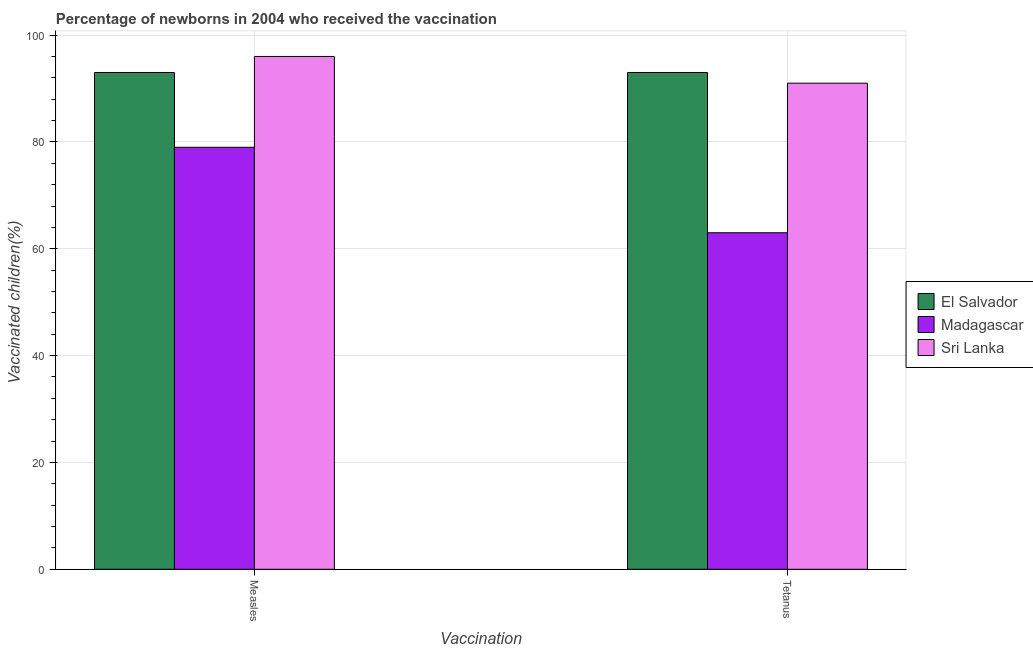How many different coloured bars are there?
Your answer should be very brief. 3. How many groups of bars are there?
Keep it short and to the point. 2. Are the number of bars on each tick of the X-axis equal?
Keep it short and to the point. Yes. How many bars are there on the 2nd tick from the left?
Give a very brief answer. 3. How many bars are there on the 1st tick from the right?
Provide a short and direct response. 3. What is the label of the 1st group of bars from the left?
Make the answer very short. Measles. What is the percentage of newborns who received vaccination for measles in El Salvador?
Offer a terse response. 93. Across all countries, what is the maximum percentage of newborns who received vaccination for measles?
Your response must be concise. 96. Across all countries, what is the minimum percentage of newborns who received vaccination for tetanus?
Ensure brevity in your answer.  63. In which country was the percentage of newborns who received vaccination for tetanus maximum?
Your answer should be compact. El Salvador. In which country was the percentage of newborns who received vaccination for tetanus minimum?
Your response must be concise. Madagascar. What is the total percentage of newborns who received vaccination for measles in the graph?
Make the answer very short. 268. What is the difference between the percentage of newborns who received vaccination for tetanus in Madagascar and that in Sri Lanka?
Offer a terse response. -28. What is the difference between the percentage of newborns who received vaccination for measles in Madagascar and the percentage of newborns who received vaccination for tetanus in Sri Lanka?
Offer a very short reply. -12. What is the average percentage of newborns who received vaccination for tetanus per country?
Keep it short and to the point. 82.33. What is the difference between the percentage of newborns who received vaccination for tetanus and percentage of newborns who received vaccination for measles in El Salvador?
Your answer should be very brief. 0. In how many countries, is the percentage of newborns who received vaccination for measles greater than 12 %?
Keep it short and to the point. 3. What is the ratio of the percentage of newborns who received vaccination for tetanus in Sri Lanka to that in El Salvador?
Your response must be concise. 0.98. In how many countries, is the percentage of newborns who received vaccination for tetanus greater than the average percentage of newborns who received vaccination for tetanus taken over all countries?
Give a very brief answer. 2. What does the 3rd bar from the left in Tetanus represents?
Keep it short and to the point. Sri Lanka. What does the 1st bar from the right in Tetanus represents?
Provide a short and direct response. Sri Lanka. How many bars are there?
Give a very brief answer. 6. Are all the bars in the graph horizontal?
Your answer should be very brief. No. How many countries are there in the graph?
Offer a very short reply. 3. What is the difference between two consecutive major ticks on the Y-axis?
Make the answer very short. 20. Does the graph contain any zero values?
Your answer should be very brief. No. Where does the legend appear in the graph?
Ensure brevity in your answer.  Center right. How are the legend labels stacked?
Provide a succinct answer. Vertical. What is the title of the graph?
Make the answer very short. Percentage of newborns in 2004 who received the vaccination. What is the label or title of the X-axis?
Give a very brief answer. Vaccination. What is the label or title of the Y-axis?
Your answer should be very brief. Vaccinated children(%)
. What is the Vaccinated children(%)
 of El Salvador in Measles?
Offer a very short reply. 93. What is the Vaccinated children(%)
 of Madagascar in Measles?
Provide a short and direct response. 79. What is the Vaccinated children(%)
 of Sri Lanka in Measles?
Offer a very short reply. 96. What is the Vaccinated children(%)
 in El Salvador in Tetanus?
Provide a short and direct response. 93. What is the Vaccinated children(%)
 of Madagascar in Tetanus?
Give a very brief answer. 63. What is the Vaccinated children(%)
 in Sri Lanka in Tetanus?
Your answer should be compact. 91. Across all Vaccination, what is the maximum Vaccinated children(%)
 in El Salvador?
Your response must be concise. 93. Across all Vaccination, what is the maximum Vaccinated children(%)
 in Madagascar?
Provide a succinct answer. 79. Across all Vaccination, what is the maximum Vaccinated children(%)
 in Sri Lanka?
Your response must be concise. 96. Across all Vaccination, what is the minimum Vaccinated children(%)
 of El Salvador?
Give a very brief answer. 93. Across all Vaccination, what is the minimum Vaccinated children(%)
 in Sri Lanka?
Your response must be concise. 91. What is the total Vaccinated children(%)
 of El Salvador in the graph?
Your answer should be very brief. 186. What is the total Vaccinated children(%)
 of Madagascar in the graph?
Provide a short and direct response. 142. What is the total Vaccinated children(%)
 in Sri Lanka in the graph?
Offer a terse response. 187. What is the difference between the Vaccinated children(%)
 in El Salvador in Measles and that in Tetanus?
Provide a short and direct response. 0. What is the difference between the Vaccinated children(%)
 of Madagascar in Measles and that in Tetanus?
Offer a very short reply. 16. What is the difference between the Vaccinated children(%)
 of El Salvador in Measles and the Vaccinated children(%)
 of Madagascar in Tetanus?
Make the answer very short. 30. What is the difference between the Vaccinated children(%)
 of El Salvador in Measles and the Vaccinated children(%)
 of Sri Lanka in Tetanus?
Keep it short and to the point. 2. What is the difference between the Vaccinated children(%)
 of Madagascar in Measles and the Vaccinated children(%)
 of Sri Lanka in Tetanus?
Give a very brief answer. -12. What is the average Vaccinated children(%)
 of El Salvador per Vaccination?
Your answer should be compact. 93. What is the average Vaccinated children(%)
 in Madagascar per Vaccination?
Offer a very short reply. 71. What is the average Vaccinated children(%)
 in Sri Lanka per Vaccination?
Your response must be concise. 93.5. What is the difference between the Vaccinated children(%)
 of El Salvador and Vaccinated children(%)
 of Madagascar in Measles?
Offer a terse response. 14. What is the difference between the Vaccinated children(%)
 in El Salvador and Vaccinated children(%)
 in Sri Lanka in Measles?
Provide a short and direct response. -3. What is the difference between the Vaccinated children(%)
 in Madagascar and Vaccinated children(%)
 in Sri Lanka in Measles?
Make the answer very short. -17. What is the difference between the Vaccinated children(%)
 in El Salvador and Vaccinated children(%)
 in Madagascar in Tetanus?
Provide a short and direct response. 30. What is the difference between the Vaccinated children(%)
 in El Salvador and Vaccinated children(%)
 in Sri Lanka in Tetanus?
Keep it short and to the point. 2. What is the difference between the Vaccinated children(%)
 of Madagascar and Vaccinated children(%)
 of Sri Lanka in Tetanus?
Provide a succinct answer. -28. What is the ratio of the Vaccinated children(%)
 in Madagascar in Measles to that in Tetanus?
Keep it short and to the point. 1.25. What is the ratio of the Vaccinated children(%)
 of Sri Lanka in Measles to that in Tetanus?
Provide a short and direct response. 1.05. What is the difference between the highest and the second highest Vaccinated children(%)
 in El Salvador?
Make the answer very short. 0. What is the difference between the highest and the second highest Vaccinated children(%)
 of Madagascar?
Your answer should be compact. 16. What is the difference between the highest and the lowest Vaccinated children(%)
 in El Salvador?
Offer a terse response. 0. 